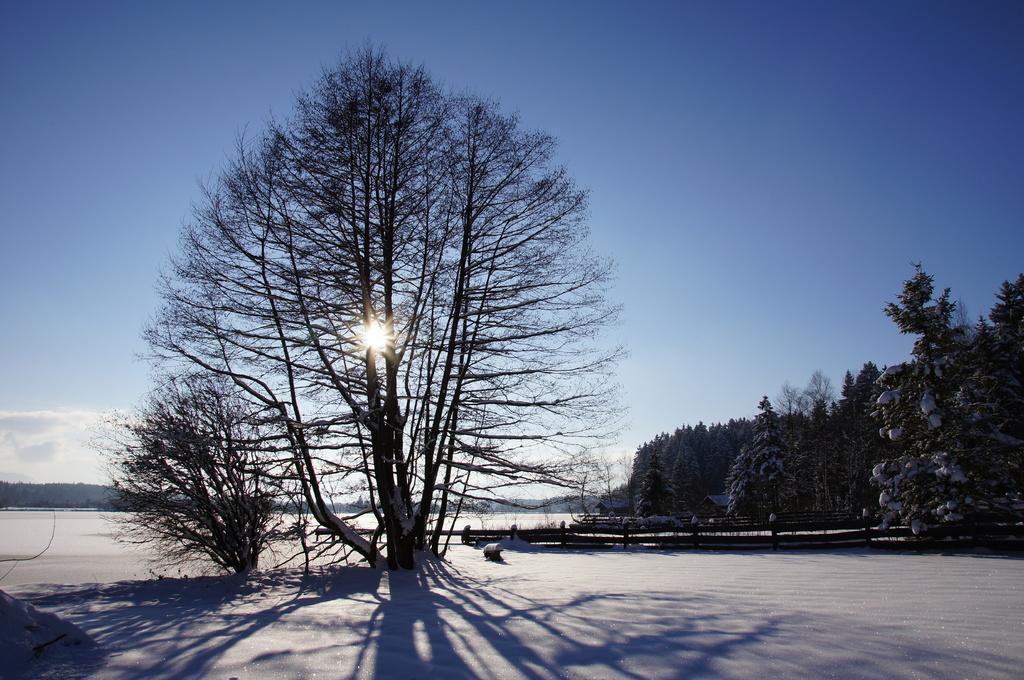Could you give a brief overview of what you see in this image? In this picture we can see the ground, trees, some objects and in the background we can see the sky. 